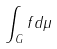Convert formula to latex. <formula><loc_0><loc_0><loc_500><loc_500>\int _ { G } f d \mu</formula> 